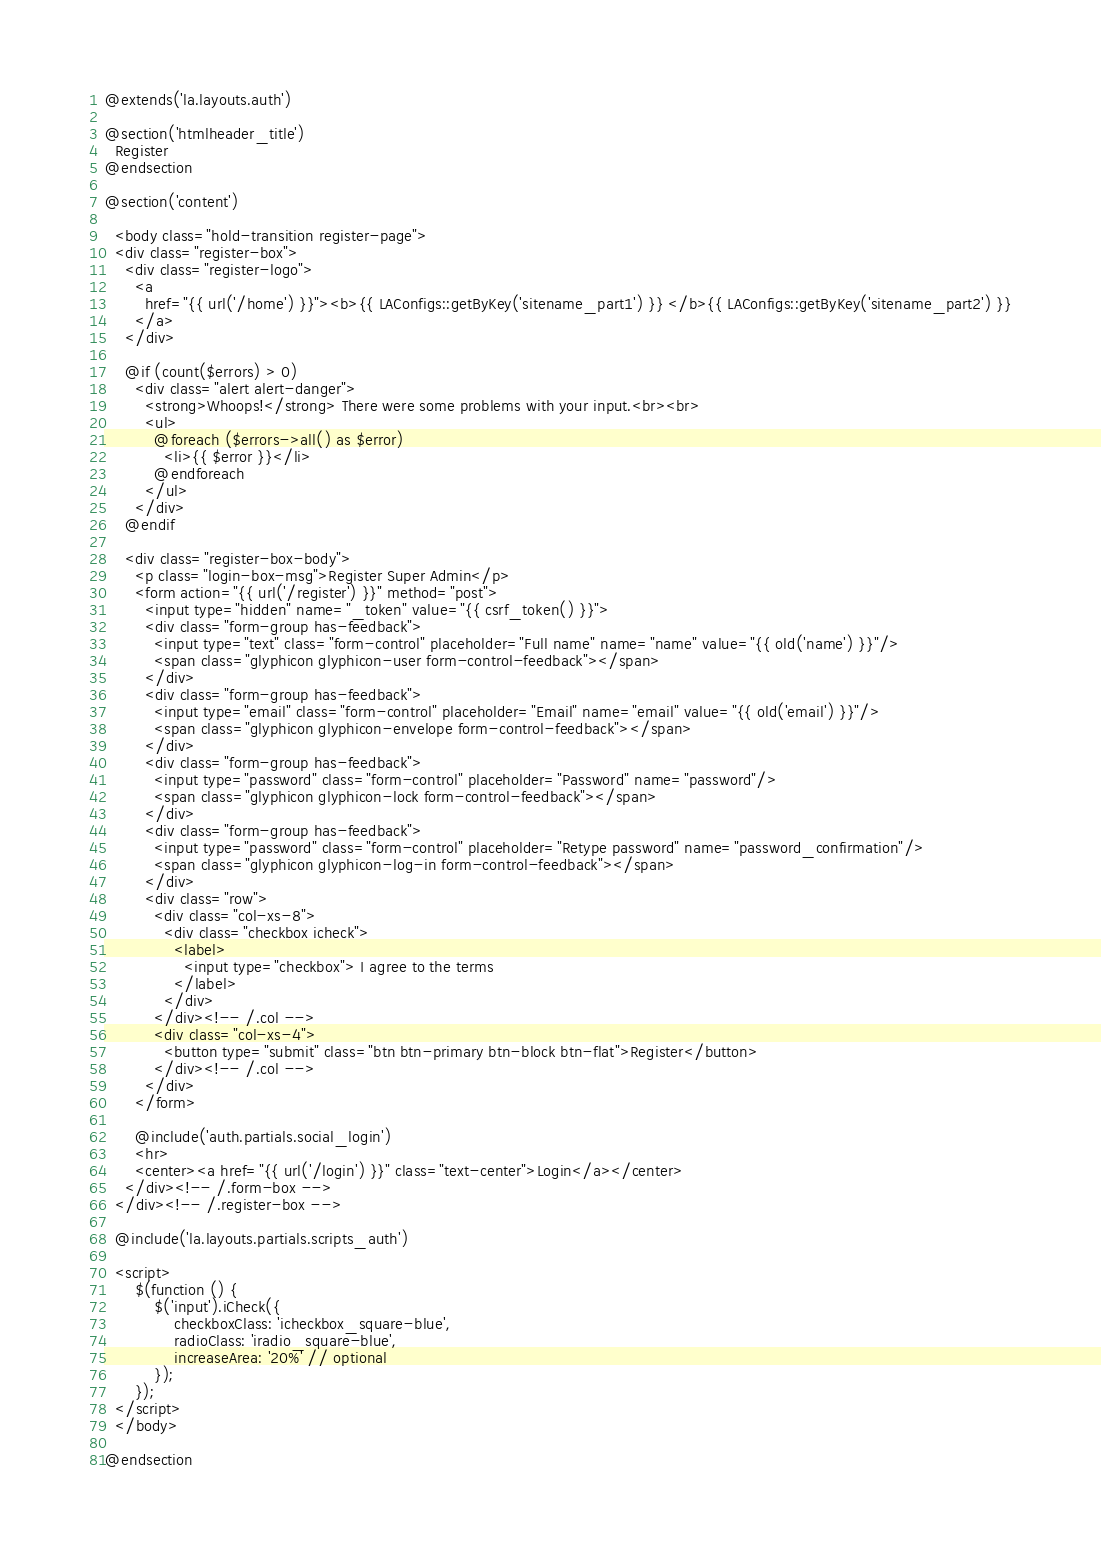<code> <loc_0><loc_0><loc_500><loc_500><_PHP_>@extends('la.layouts.auth')

@section('htmlheader_title')
  Register
@endsection

@section('content')

  <body class="hold-transition register-page">
  <div class="register-box">
    <div class="register-logo">
      <a
        href="{{ url('/home') }}"><b>{{ LAConfigs::getByKey('sitename_part1') }} </b>{{ LAConfigs::getByKey('sitename_part2') }}
      </a>
    </div>

    @if (count($errors) > 0)
      <div class="alert alert-danger">
        <strong>Whoops!</strong> There were some problems with your input.<br><br>
        <ul>
          @foreach ($errors->all() as $error)
            <li>{{ $error }}</li>
          @endforeach
        </ul>
      </div>
    @endif

    <div class="register-box-body">
      <p class="login-box-msg">Register Super Admin</p>
      <form action="{{ url('/register') }}" method="post">
        <input type="hidden" name="_token" value="{{ csrf_token() }}">
        <div class="form-group has-feedback">
          <input type="text" class="form-control" placeholder="Full name" name="name" value="{{ old('name') }}"/>
          <span class="glyphicon glyphicon-user form-control-feedback"></span>
        </div>
        <div class="form-group has-feedback">
          <input type="email" class="form-control" placeholder="Email" name="email" value="{{ old('email') }}"/>
          <span class="glyphicon glyphicon-envelope form-control-feedback"></span>
        </div>
        <div class="form-group has-feedback">
          <input type="password" class="form-control" placeholder="Password" name="password"/>
          <span class="glyphicon glyphicon-lock form-control-feedback"></span>
        </div>
        <div class="form-group has-feedback">
          <input type="password" class="form-control" placeholder="Retype password" name="password_confirmation"/>
          <span class="glyphicon glyphicon-log-in form-control-feedback"></span>
        </div>
        <div class="row">
          <div class="col-xs-8">
            <div class="checkbox icheck">
              <label>
                <input type="checkbox"> I agree to the terms
              </label>
            </div>
          </div><!-- /.col -->
          <div class="col-xs-4">
            <button type="submit" class="btn btn-primary btn-block btn-flat">Register</button>
          </div><!-- /.col -->
        </div>
      </form>

      @include('auth.partials.social_login')
      <hr>
      <center><a href="{{ url('/login') }}" class="text-center">Login</a></center>
    </div><!-- /.form-box -->
  </div><!-- /.register-box -->

  @include('la.layouts.partials.scripts_auth')

  <script>
      $(function () {
          $('input').iCheck({
              checkboxClass: 'icheckbox_square-blue',
              radioClass: 'iradio_square-blue',
              increaseArea: '20%' // optional
          });
      });
  </script>
  </body>

@endsection
</code> 